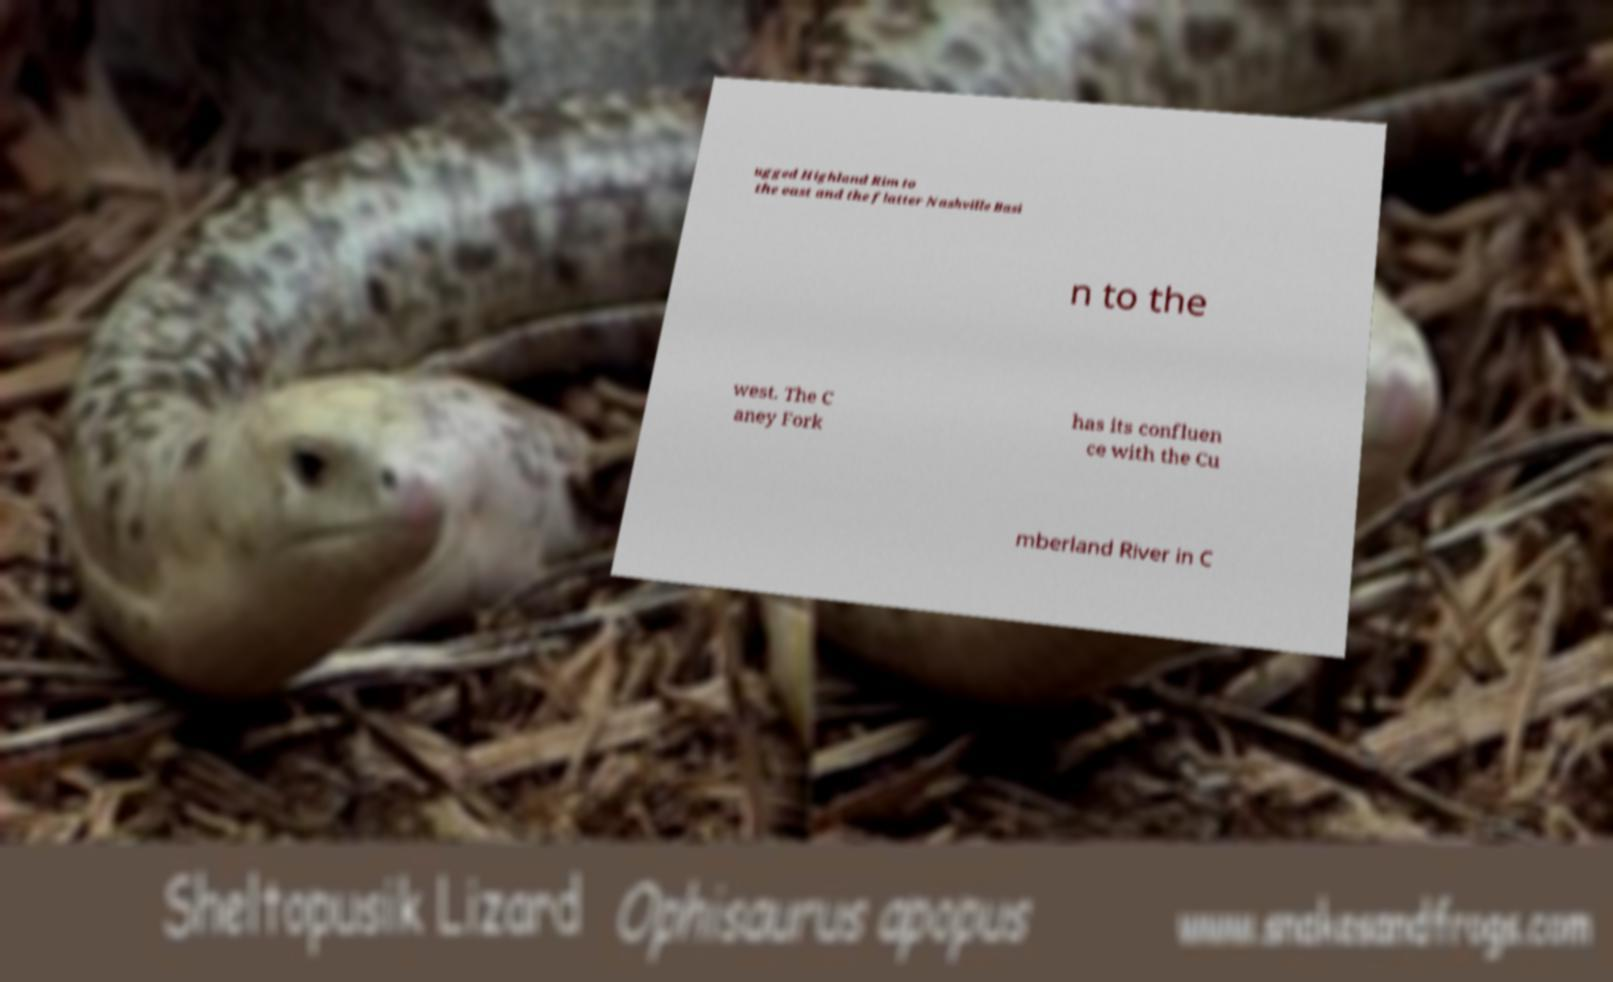Please read and relay the text visible in this image. What does it say? ugged Highland Rim to the east and the flatter Nashville Basi n to the west. The C aney Fork has its confluen ce with the Cu mberland River in C 